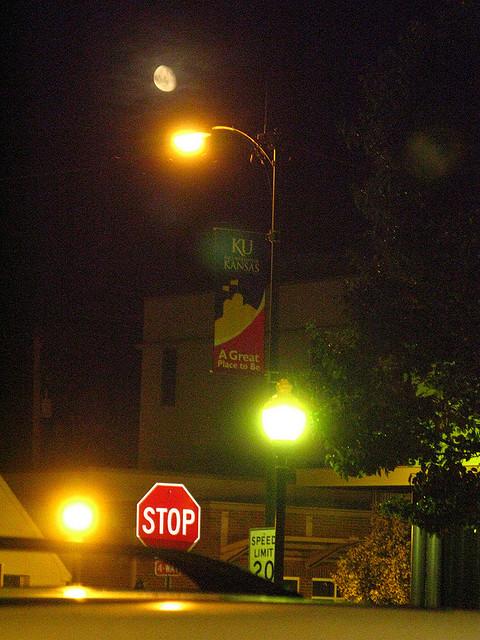What is the speed limit?
Give a very brief answer. 20. What is the signs saying?
Concise answer only. Stop. Is it daytime?
Concise answer only. No. Is it late?
Be succinct. Yes. 